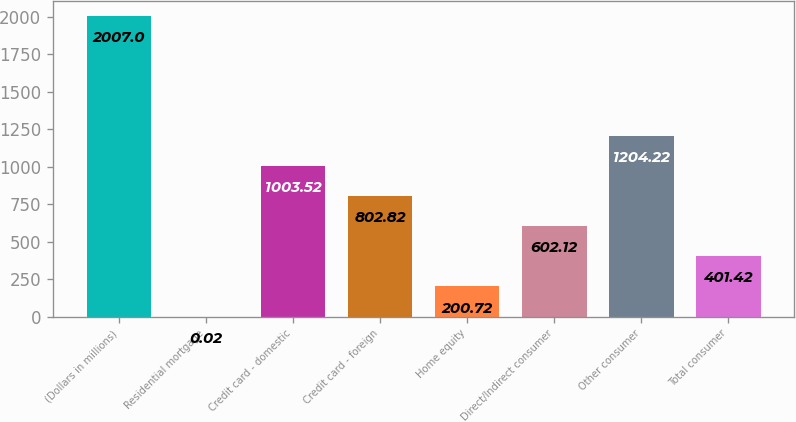Convert chart. <chart><loc_0><loc_0><loc_500><loc_500><bar_chart><fcel>(Dollars in millions)<fcel>Residential mortgage<fcel>Credit card - domestic<fcel>Credit card - foreign<fcel>Home equity<fcel>Direct/Indirect consumer<fcel>Other consumer<fcel>Total consumer<nl><fcel>2007<fcel>0.02<fcel>1003.52<fcel>802.82<fcel>200.72<fcel>602.12<fcel>1204.22<fcel>401.42<nl></chart> 